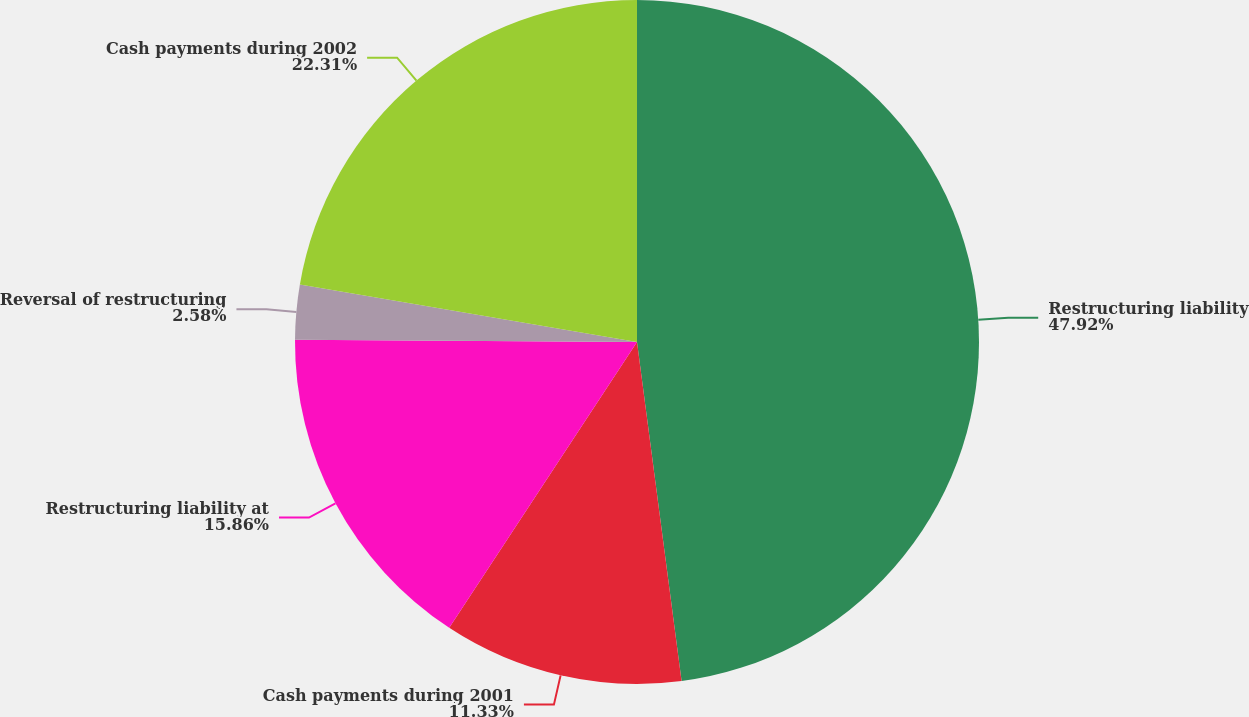<chart> <loc_0><loc_0><loc_500><loc_500><pie_chart><fcel>Restructuring liability<fcel>Cash payments during 2001<fcel>Restructuring liability at<fcel>Reversal of restructuring<fcel>Cash payments during 2002<nl><fcel>47.92%<fcel>11.33%<fcel>15.86%<fcel>2.58%<fcel>22.31%<nl></chart> 